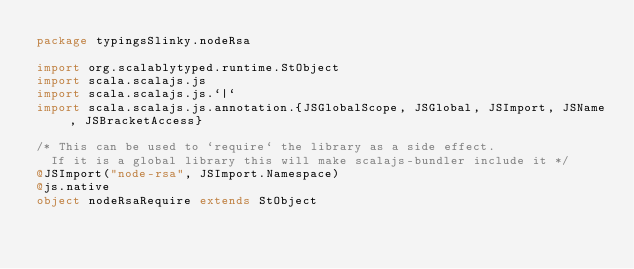<code> <loc_0><loc_0><loc_500><loc_500><_Scala_>package typingsSlinky.nodeRsa

import org.scalablytyped.runtime.StObject
import scala.scalajs.js
import scala.scalajs.js.`|`
import scala.scalajs.js.annotation.{JSGlobalScope, JSGlobal, JSImport, JSName, JSBracketAccess}

/* This can be used to `require` the library as a side effect.
  If it is a global library this will make scalajs-bundler include it */
@JSImport("node-rsa", JSImport.Namespace)
@js.native
object nodeRsaRequire extends StObject
</code> 